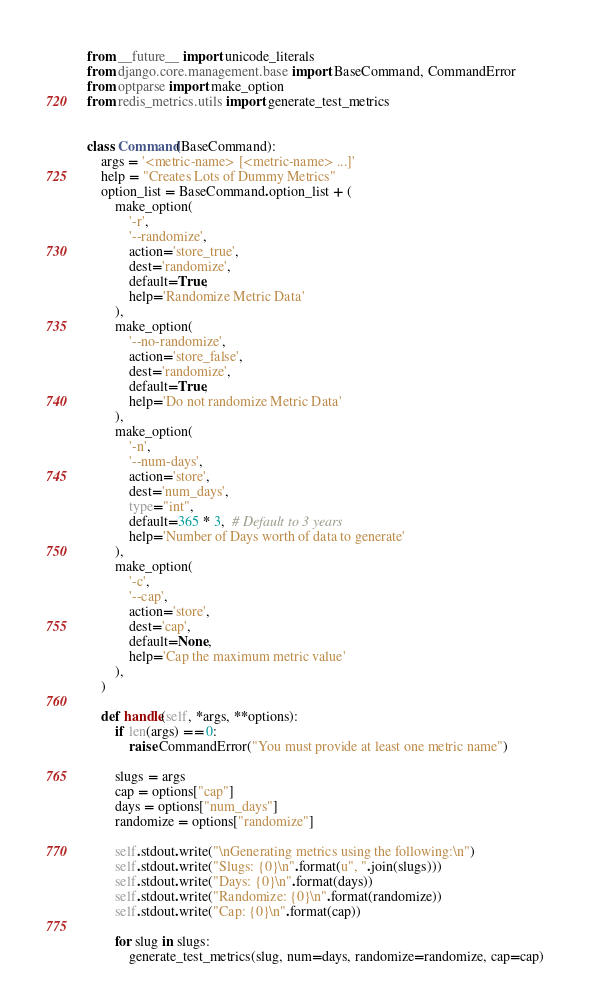Convert code to text. <code><loc_0><loc_0><loc_500><loc_500><_Python_>from __future__ import unicode_literals
from django.core.management.base import BaseCommand, CommandError
from optparse import make_option
from redis_metrics.utils import generate_test_metrics


class Command(BaseCommand):
    args = '<metric-name> [<metric-name> ...]'
    help = "Creates Lots of Dummy Metrics"
    option_list = BaseCommand.option_list + (
        make_option(
            '-r',
            '--randomize',
            action='store_true',
            dest='randomize',
            default=True,
            help='Randomize Metric Data'
        ),
        make_option(
            '--no-randomize',
            action='store_false',
            dest='randomize',
            default=True,
            help='Do not randomize Metric Data'
        ),
        make_option(
            '-n',
            '--num-days',
            action='store',
            dest='num_days',
            type="int",
            default=365 * 3,  # Default to 3 years
            help='Number of Days worth of data to generate'
        ),
        make_option(
            '-c',
            '--cap',
            action='store',
            dest='cap',
            default=None,
            help='Cap the maximum metric value'
        ),
    )

    def handle(self, *args, **options):
        if len(args) == 0:
            raise CommandError("You must provide at least one metric name")

        slugs = args
        cap = options["cap"]
        days = options["num_days"]
        randomize = options["randomize"]

        self.stdout.write("\nGenerating metrics using the following:\n")
        self.stdout.write("Slugs: {0}\n".format(u", ".join(slugs)))
        self.stdout.write("Days: {0}\n".format(days))
        self.stdout.write("Randomize: {0}\n".format(randomize))
        self.stdout.write("Cap: {0}\n".format(cap))

        for slug in slugs:
            generate_test_metrics(slug, num=days, randomize=randomize, cap=cap)
</code> 